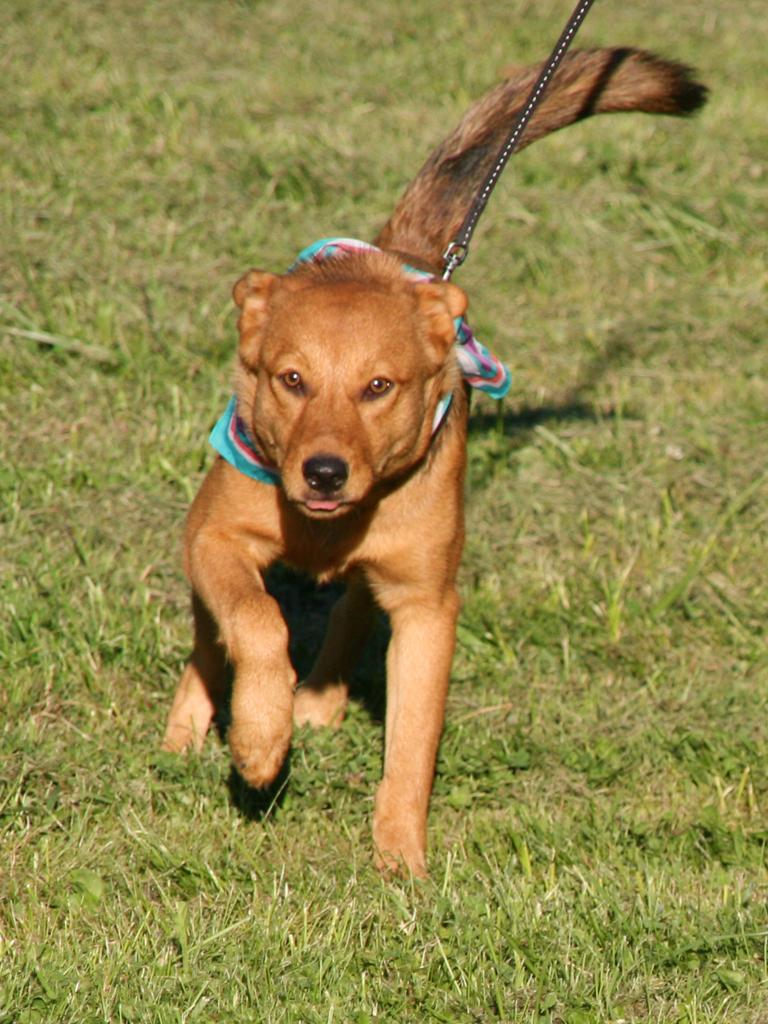What animal can be seen in the image? There is a dog in the image. What is the dog doing in the image? The dog is running on the ground. Is there any equipment associated with the dog in the image? Yes, there is a dog belt in the image. What type of surface is the dog running on? There is grass on the ground in the image. How long does it take for the dog to read a book in the image? There is no book present in the image, and dogs do not have the ability to read. 